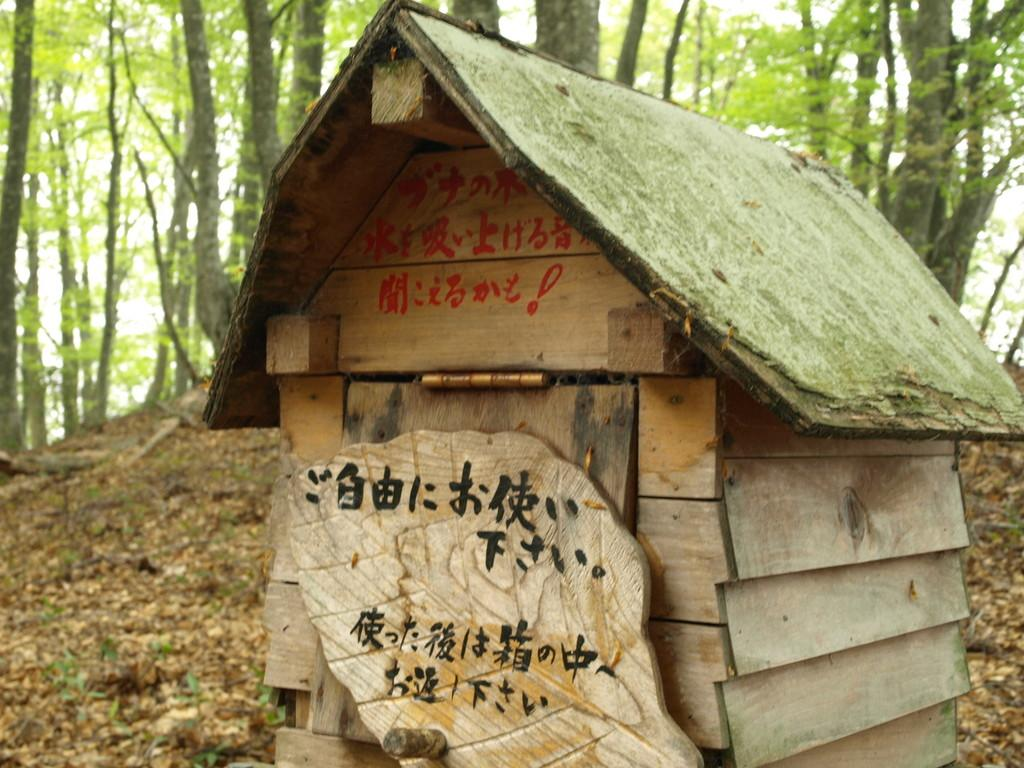What type of structure is present in the image? There is a wooden hut in the image. What can be seen in the background of the image? There are trees visible in the image. What is on the ground in the image? There are leaves on the ground in the image. How many pies are being baked inside the wooden hut in the image? There is no indication of pies or baking in the image; it only shows a wooden hut, trees, and leaves on the ground. 